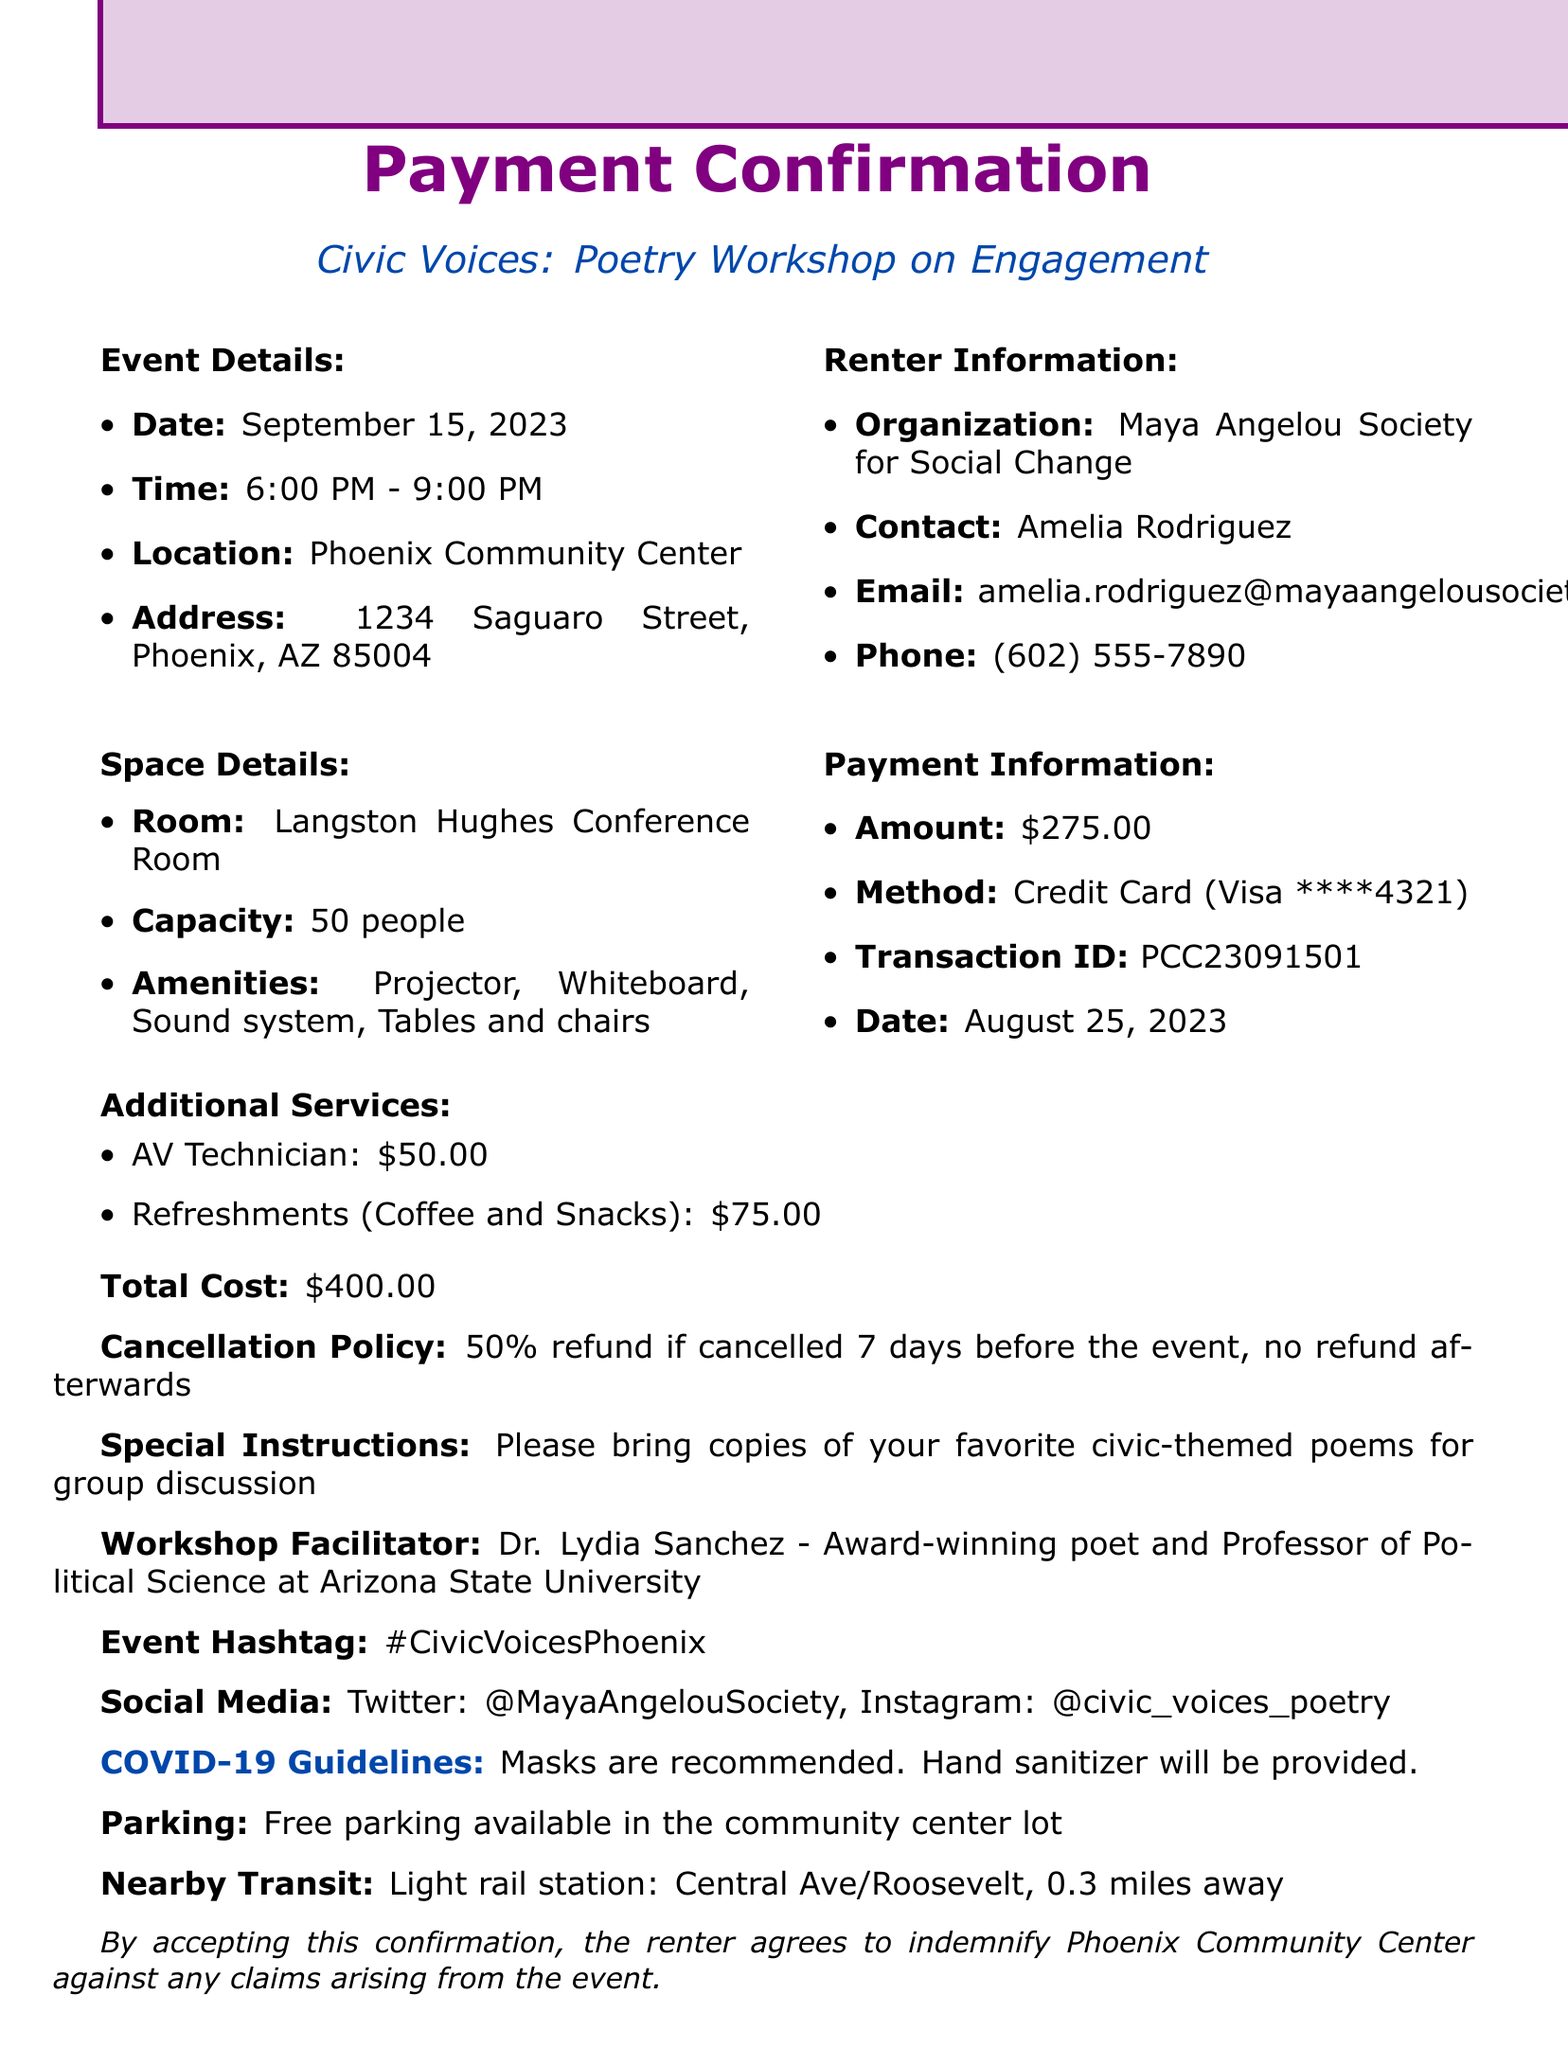What is the event name? The event name is a key detail outlined in the document, specified under event details.
Answer: Civic Voices: Poetry Workshop on Engagement What is the total cost? The total cost summarizes the rental fee and additional services provided in the payment information section.
Answer: $400.00 Who is the contact person for the renter? The contact person's name is explicitly mentioned in the renter information section of the document.
Answer: Amelia Rodriguez What is the payment method used? The payment method is used to describe how the payment was processed, indicated in the payment information.
Answer: Credit Card What time does the event start? The starting time of the event is detailed in the event details section and is crucial for participants.
Answer: 6:00 PM What is the cancellation policy? The cancellation policy is provided to inform the renter about refund terms if the event is canceled.
Answer: 50% refund if cancelled 7 days before the event, no refund afterwards What additional service costs $50.00? The additional services include specific costs, and one of them is listed under the additional services section.
Answer: AV Technician Where is the workshop being held? The location of the workshop is mentioned as part of the event details in the document.
Answer: Phoenix Community Center Who is the workshop facilitator? The name of the workshop facilitator is specifically mentioned in the document, along with their credentials.
Answer: Dr. Lydia Sanchez 